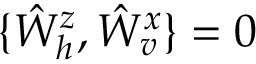<formula> <loc_0><loc_0><loc_500><loc_500>\{ \hat { W } _ { h } ^ { z } , \hat { W } _ { v } ^ { x } \} = 0</formula> 